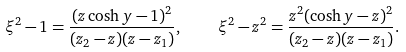Convert formula to latex. <formula><loc_0><loc_0><loc_500><loc_500>\xi ^ { 2 } - 1 = \frac { ( z \cosh y - 1 ) ^ { 2 } } { ( z _ { 2 } - z ) ( z - z _ { 1 } ) } , \quad \xi ^ { 2 } - z ^ { 2 } = \frac { z ^ { 2 } ( \cosh y - z ) ^ { 2 } } { ( z _ { 2 } - z ) ( z - z _ { 1 } ) } .</formula> 